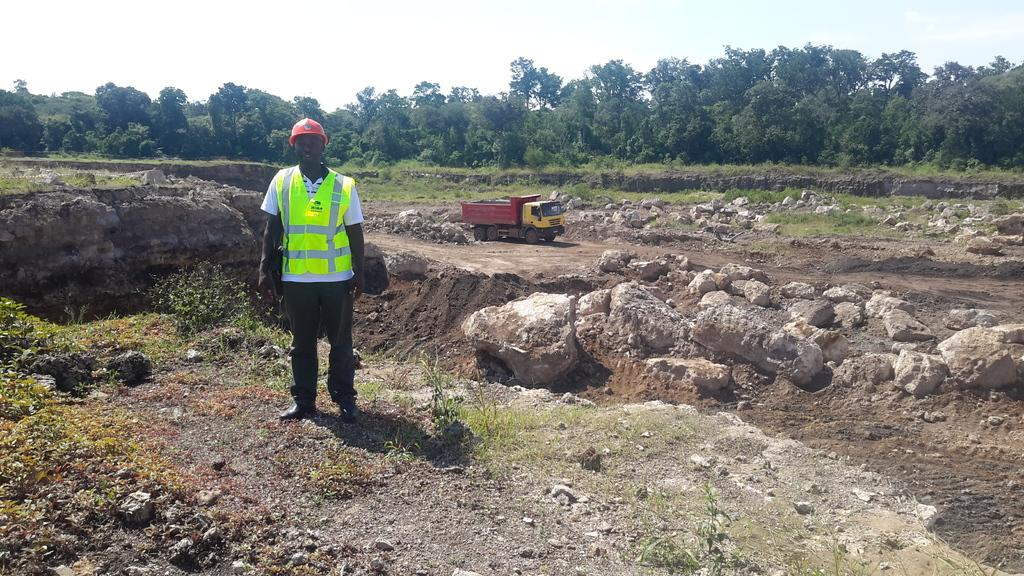What type of natural elements can be seen in the image? There are trees, rocks, grass, and mud in the image. What man-made object is present in the image? There is a vehicle in the image. What is visible in the background of the image? The sky is visible in the image. What is the person in the image wearing? The person is wearing a helmet. How much money does the servant in the image have? There is no servant or money present in the image. Who is the partner of the person in the image? There is no partner mentioned or visible in the image. 